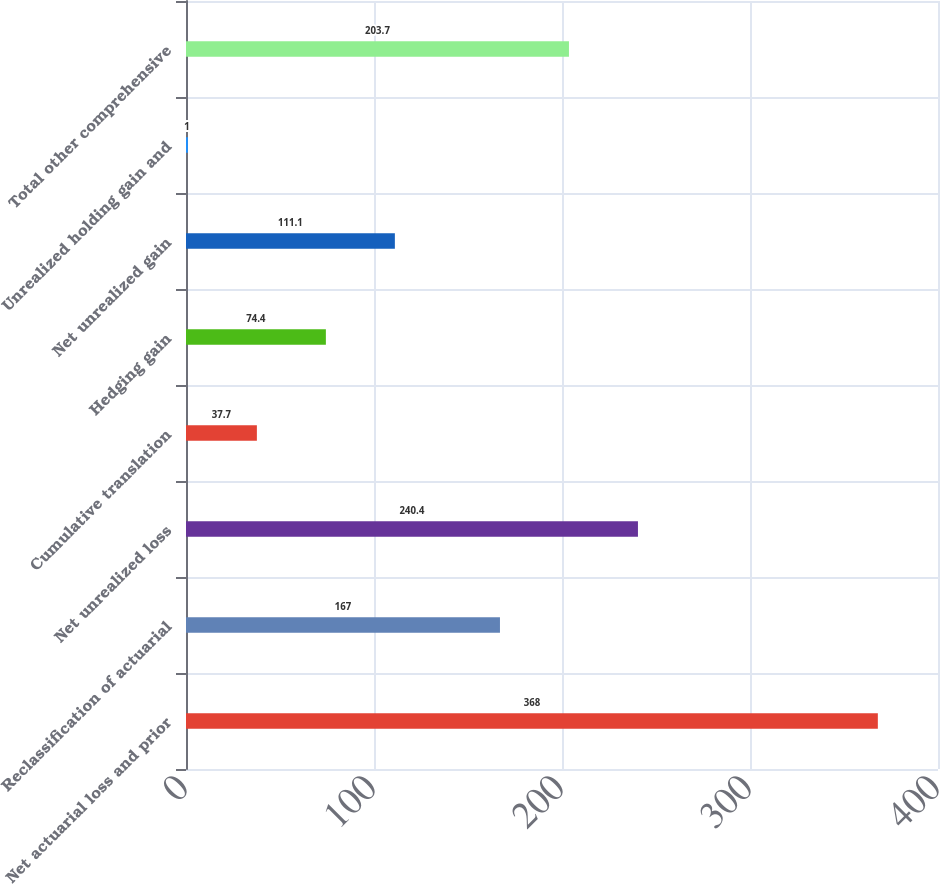Convert chart. <chart><loc_0><loc_0><loc_500><loc_500><bar_chart><fcel>Net actuarial loss and prior<fcel>Reclassification of actuarial<fcel>Net unrealized loss<fcel>Cumulative translation<fcel>Hedging gain<fcel>Net unrealized gain<fcel>Unrealized holding gain and<fcel>Total other comprehensive<nl><fcel>368<fcel>167<fcel>240.4<fcel>37.7<fcel>74.4<fcel>111.1<fcel>1<fcel>203.7<nl></chart> 